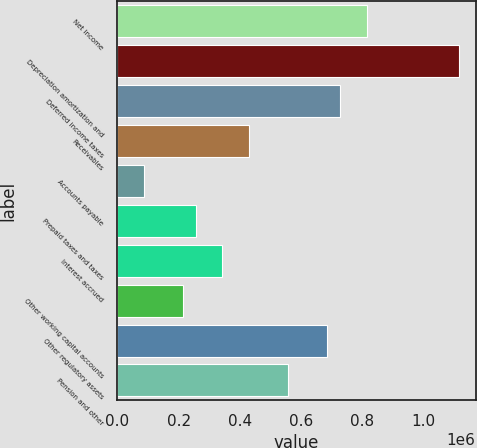Convert chart. <chart><loc_0><loc_0><loc_500><loc_500><bar_chart><fcel>Net income<fcel>Depreciation amortization and<fcel>Deferred income taxes<fcel>Receivables<fcel>Accounts payable<fcel>Prepaid taxes and taxes<fcel>Interest accrued<fcel>Other working capital accounts<fcel>Other regulatory assets<fcel>Pension and other<nl><fcel>813677<fcel>1.11344e+06<fcel>728030<fcel>428265<fcel>85676.2<fcel>256971<fcel>342618<fcel>214147<fcel>685207<fcel>556736<nl></chart> 